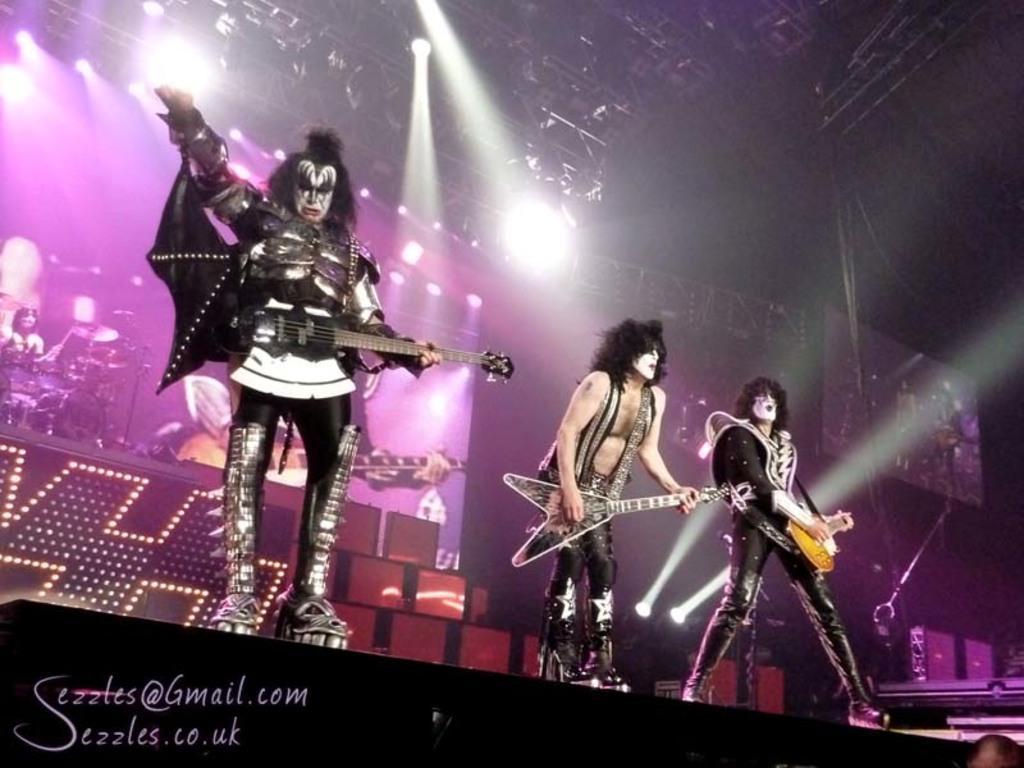In one or two sentences, can you explain what this image depicts? This 3 persons are standing and playing a guitar. Far there are focusing lights. On a banner there are musical instruments. 